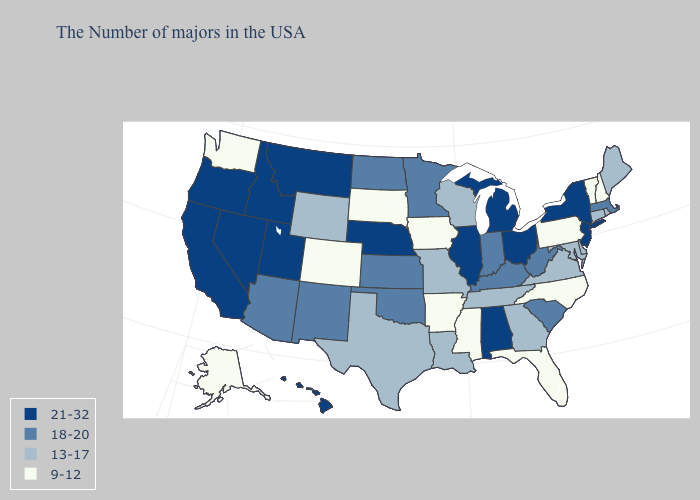Does Wisconsin have the lowest value in the MidWest?
Quick response, please. No. Does the map have missing data?
Concise answer only. No. What is the value of New Mexico?
Short answer required. 18-20. Name the states that have a value in the range 9-12?
Quick response, please. New Hampshire, Vermont, Pennsylvania, North Carolina, Florida, Mississippi, Arkansas, Iowa, South Dakota, Colorado, Washington, Alaska. Among the states that border Colorado , does Utah have the lowest value?
Keep it brief. No. Name the states that have a value in the range 18-20?
Keep it brief. Massachusetts, South Carolina, West Virginia, Kentucky, Indiana, Minnesota, Kansas, Oklahoma, North Dakota, New Mexico, Arizona. Does the map have missing data?
Be succinct. No. What is the value of New Hampshire?
Keep it brief. 9-12. What is the value of Maryland?
Answer briefly. 13-17. Name the states that have a value in the range 13-17?
Quick response, please. Maine, Rhode Island, Connecticut, Delaware, Maryland, Virginia, Georgia, Tennessee, Wisconsin, Louisiana, Missouri, Texas, Wyoming. Is the legend a continuous bar?
Quick response, please. No. Which states have the lowest value in the West?
Keep it brief. Colorado, Washington, Alaska. What is the highest value in states that border West Virginia?
Give a very brief answer. 21-32. Which states hav the highest value in the Northeast?
Give a very brief answer. New York, New Jersey. Does Colorado have the lowest value in the West?
Quick response, please. Yes. 